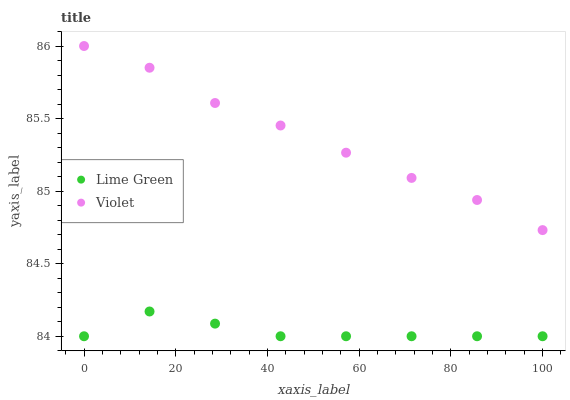Does Lime Green have the minimum area under the curve?
Answer yes or no. Yes. Does Violet have the maximum area under the curve?
Answer yes or no. Yes. Does Violet have the minimum area under the curve?
Answer yes or no. No. Is Violet the smoothest?
Answer yes or no. Yes. Is Lime Green the roughest?
Answer yes or no. Yes. Is Violet the roughest?
Answer yes or no. No. Does Lime Green have the lowest value?
Answer yes or no. Yes. Does Violet have the lowest value?
Answer yes or no. No. Does Violet have the highest value?
Answer yes or no. Yes. Is Lime Green less than Violet?
Answer yes or no. Yes. Is Violet greater than Lime Green?
Answer yes or no. Yes. Does Lime Green intersect Violet?
Answer yes or no. No. 